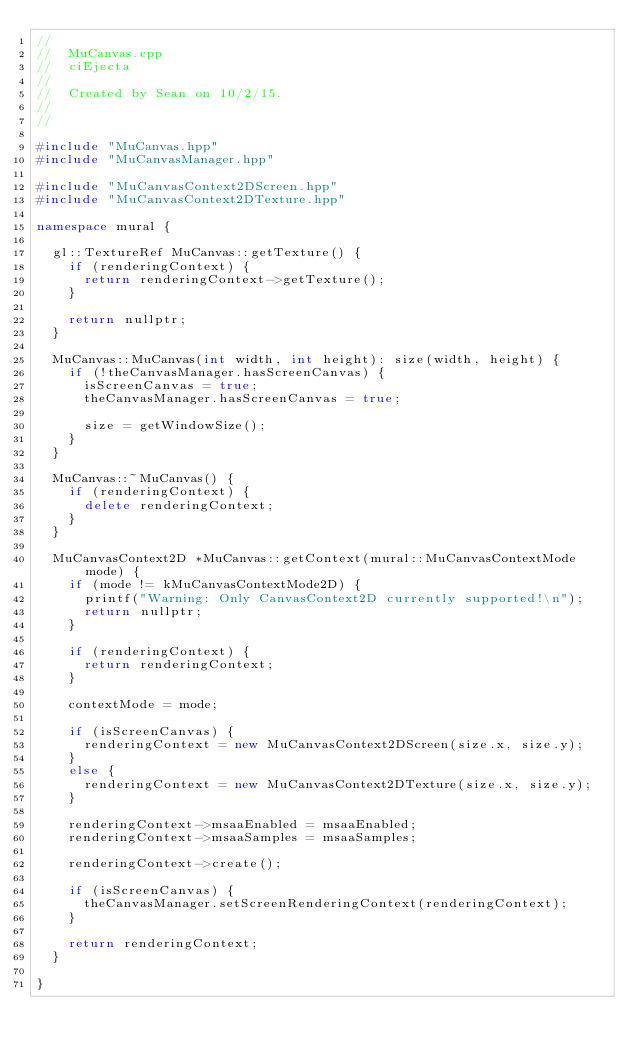<code> <loc_0><loc_0><loc_500><loc_500><_C++_>//
//  MuCanvas.cpp
//  ciEjecta
//
//  Created by Sean on 10/2/15.
//
//

#include "MuCanvas.hpp"
#include "MuCanvasManager.hpp"

#include "MuCanvasContext2DScreen.hpp"
#include "MuCanvasContext2DTexture.hpp"

namespace mural {

  gl::TextureRef MuCanvas::getTexture() {
    if (renderingContext) {
      return renderingContext->getTexture();
    }

    return nullptr;
  }

  MuCanvas::MuCanvas(int width, int height): size(width, height) {
    if (!theCanvasManager.hasScreenCanvas) {
      isScreenCanvas = true;
      theCanvasManager.hasScreenCanvas = true;

      size = getWindowSize();
    }
  }

  MuCanvas::~MuCanvas() {
    if (renderingContext) {
      delete renderingContext;
    }
  }

  MuCanvasContext2D *MuCanvas::getContext(mural::MuCanvasContextMode mode) {
    if (mode != kMuCanvasContextMode2D) {
      printf("Warning: Only CanvasContext2D currently supported!\n");
      return nullptr;
    }

    if (renderingContext) {
      return renderingContext;
    }

    contextMode = mode;

    if (isScreenCanvas) {
      renderingContext = new MuCanvasContext2DScreen(size.x, size.y);
    }
    else {
      renderingContext = new MuCanvasContext2DTexture(size.x, size.y);
    }

    renderingContext->msaaEnabled = msaaEnabled;
    renderingContext->msaaSamples = msaaSamples;

    renderingContext->create();

    if (isScreenCanvas) {
      theCanvasManager.setScreenRenderingContext(renderingContext);
    }

    return renderingContext;
  }

}
</code> 